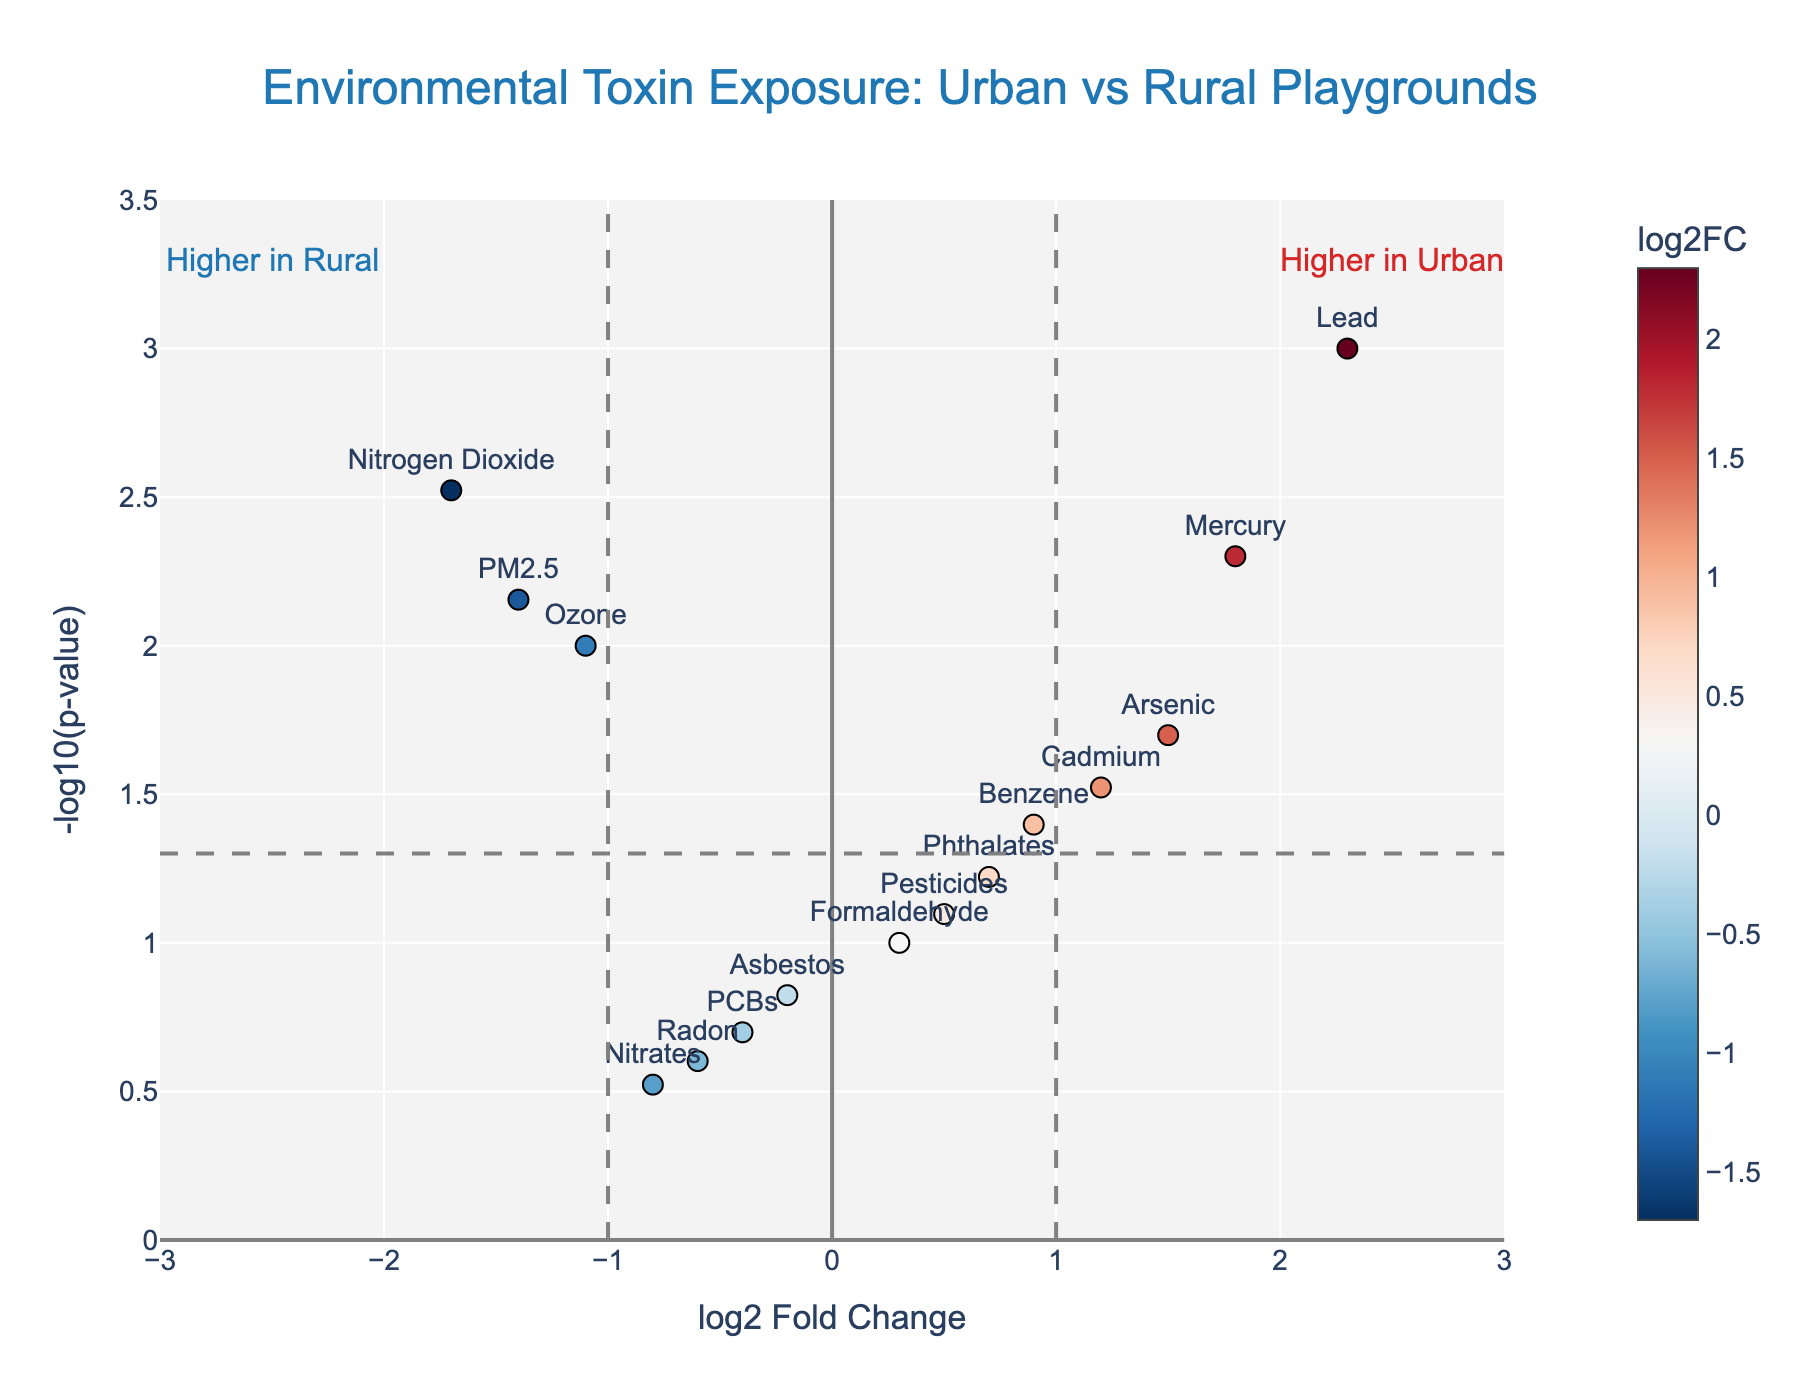What is the title of the plot? The title is displayed at the top of the plot and gives a concise description of the data being represented.
Answer: Environmental Toxin Exposure: Urban vs Rural Playgrounds How many chemicals have a p-value less than 0.05? To answer this, we need to count the number of points above the horizontal dashed line, which represents the p-value threshold of 0.05.
Answer: 5 Which chemical has the highest log2 fold change? To determine this, find the point furthest to the right on the x-axis, which represents log2 fold change.
Answer: Lead Which chemical is most significantly different between urban and rural playgrounds? This can be inferred from the point with the highest -log10(p-value), meaning the point highest on the y-axis.
Answer: Lead Which chemicals are more prevalent in urban playgrounds compared to rural ones? Chemicals with a positive log2 fold change are more prevalent in urban playgrounds. These are to the right of the x=1 dashed line.
Answer: Lead, Mercury, Arsenic, Cadmium, Benzene What is the approximate p-value for Ozone? Find the position of Ozone on the y-axis, which corresponds to its -log10(p-value), and convert it back to a p-value. Ozone has a -log10(p-value) of approximately 2, meaning 10^-2.
Answer: 0.01 Which chemicals have a negative log2 fold change and a p-value less than 0.05? Identify points to the left of x=-1 with a -log10(p-value) higher than the horizontal dashed line.
Answer: Ozone, PM2.5, Nitrogen Dioxide How many toxins have a fold change greater than 1? Count the number of points to the right of the vertical dashed line at log2 fold change = 1.
Answer: 3 What direction does the fold change for Asbestos indicate, and is it statistically significant? Asbestos lies to the left of the x-axis's origin, showing a negative fold change. Its -log10(p-value) is less than the dashed line, indicating it is not statistically significant.
Answer: Rural, No 